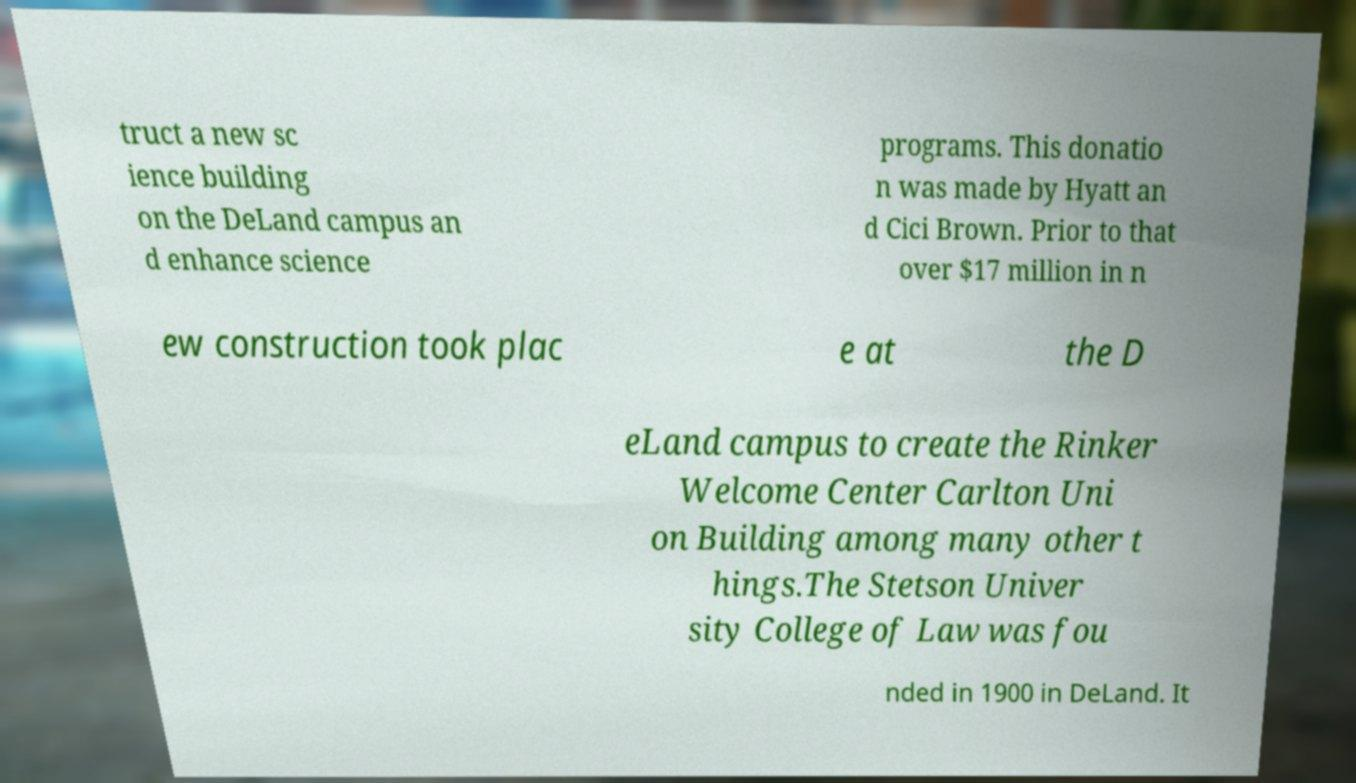Can you read and provide the text displayed in the image?This photo seems to have some interesting text. Can you extract and type it out for me? truct a new sc ience building on the DeLand campus an d enhance science programs. This donatio n was made by Hyatt an d Cici Brown. Prior to that over $17 million in n ew construction took plac e at the D eLand campus to create the Rinker Welcome Center Carlton Uni on Building among many other t hings.The Stetson Univer sity College of Law was fou nded in 1900 in DeLand. It 